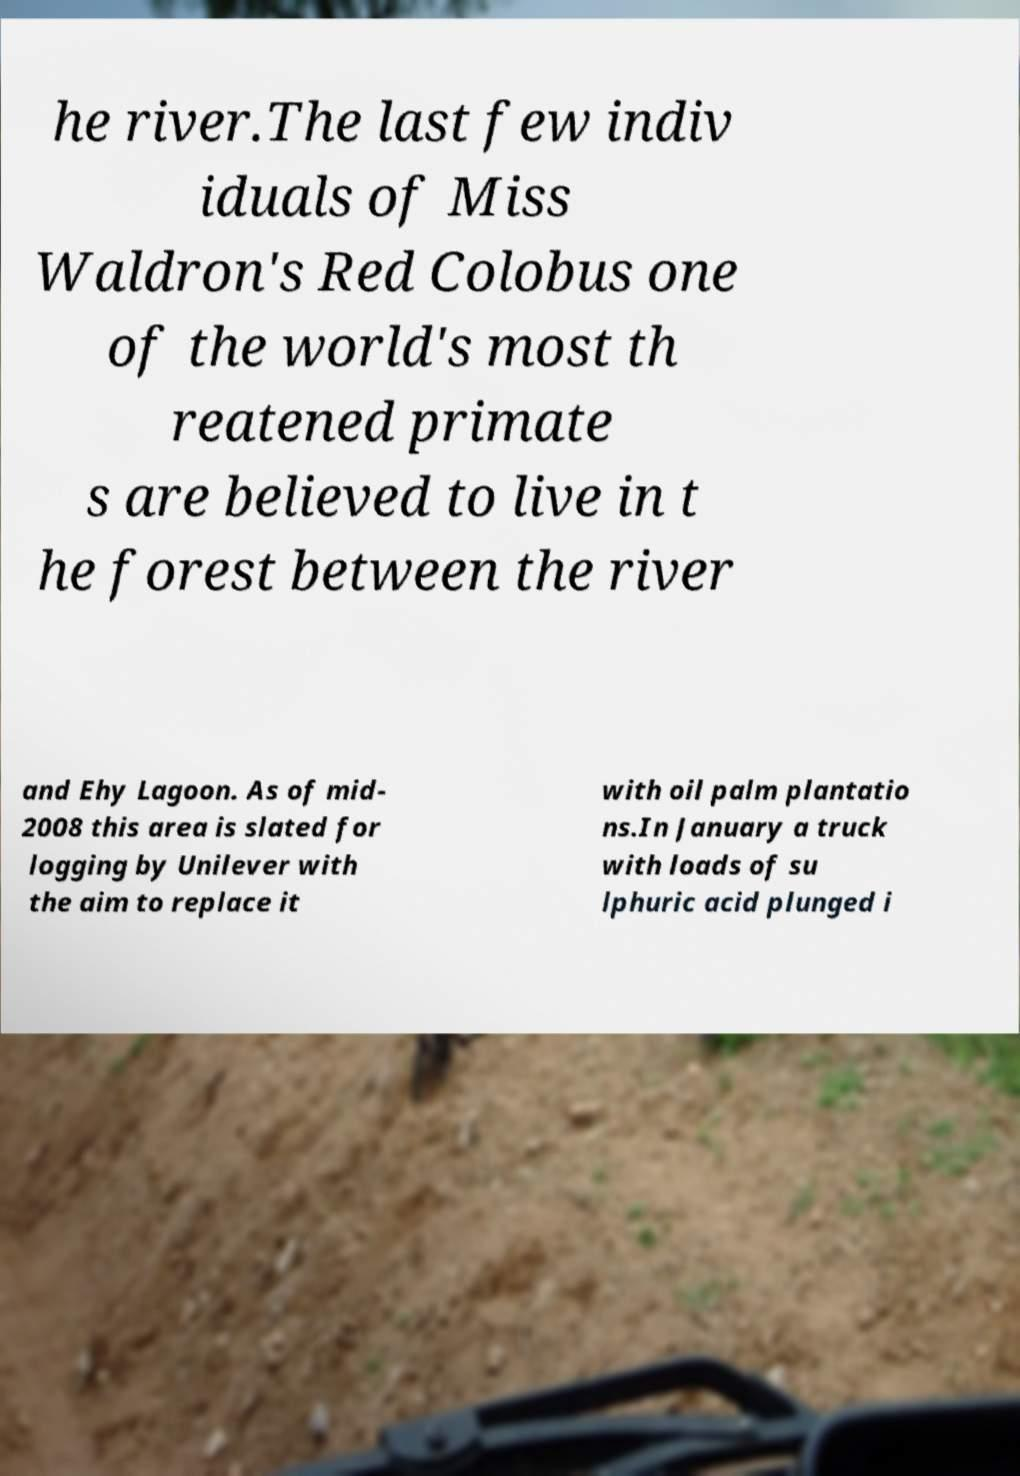Can you read and provide the text displayed in the image?This photo seems to have some interesting text. Can you extract and type it out for me? he river.The last few indiv iduals of Miss Waldron's Red Colobus one of the world's most th reatened primate s are believed to live in t he forest between the river and Ehy Lagoon. As of mid- 2008 this area is slated for logging by Unilever with the aim to replace it with oil palm plantatio ns.In January a truck with loads of su lphuric acid plunged i 